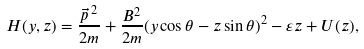Convert formula to latex. <formula><loc_0><loc_0><loc_500><loc_500>H ( y , z ) = \frac { \vec { p } \, ^ { 2 } } { 2 m } + \frac { B ^ { 2 } } { 2 m } ( y \cos \theta - z \sin \theta ) ^ { 2 } - { \varepsilon } z + U ( z ) ,</formula> 